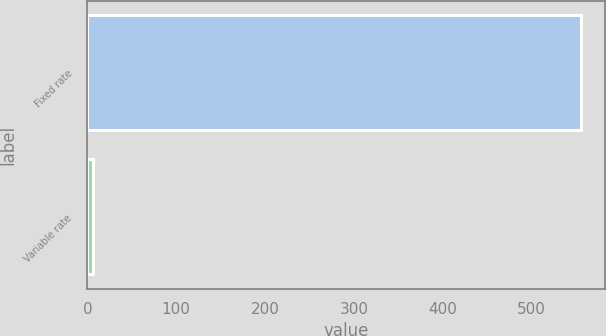<chart> <loc_0><loc_0><loc_500><loc_500><bar_chart><fcel>Fixed rate<fcel>Variable rate<nl><fcel>555<fcel>6.3<nl></chart> 